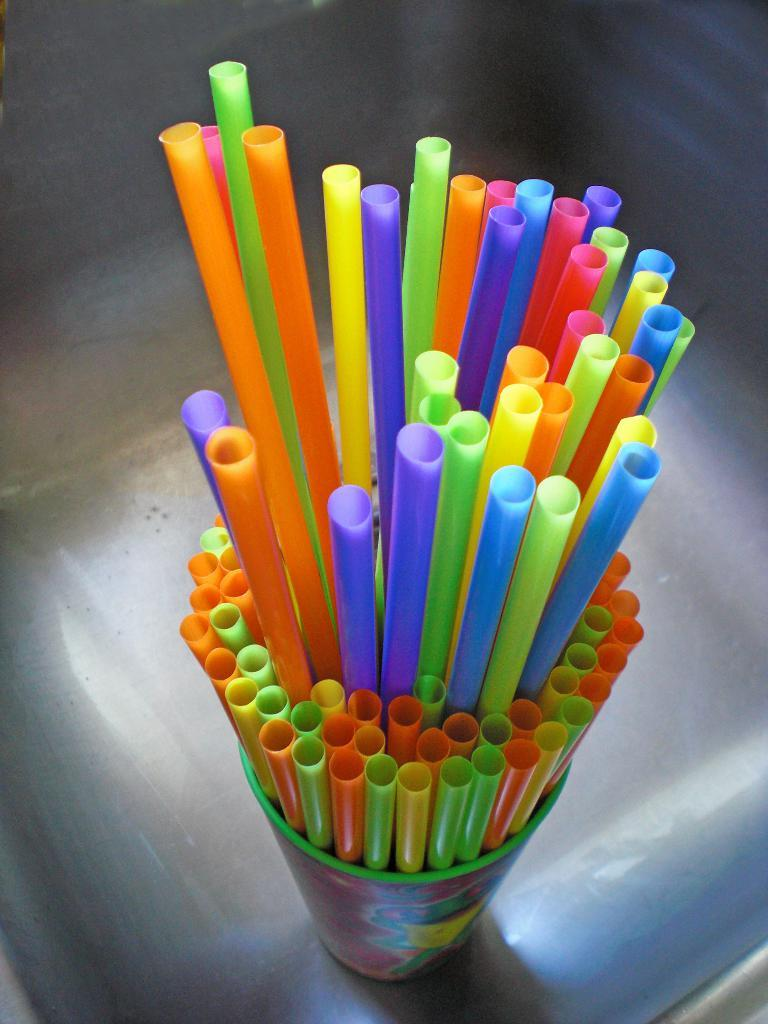What objects are in the image? There are pipes of different colors in the image. How are the pipes arranged in the image? The pipes are in a glass. Where is the glass with pipes located? The glass with pipes is placed on a surface. What type of tax is being discussed in the image? There is no discussion of tax in the image; it features pipes in a glass on a surface. 